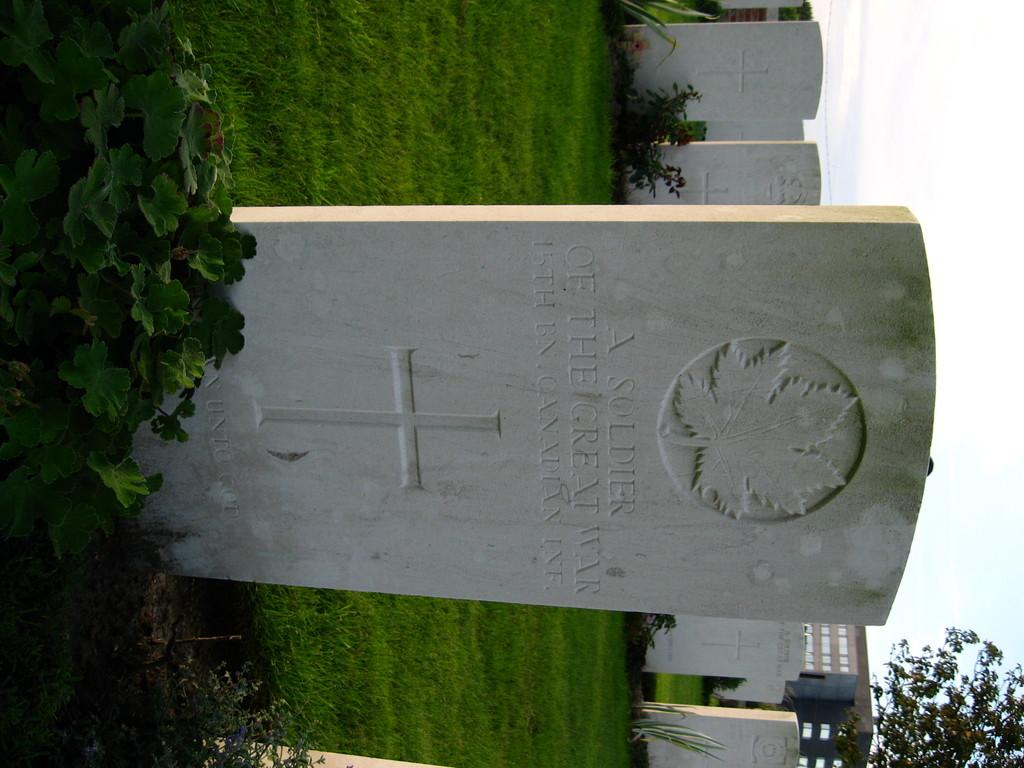What type of structures can be seen in the image? There are headstones and a building in the image. What type of vegetation is present in the image? There are plants and grass in the image. What type of tree is visible in the image? There is a tree in the image. What is visible in the background of the image? The sky is visible in the background of the image. What size of honey can be seen in the image? There is no honey present in the image. What type of stage is visible in the image? There is no stage present in the image. 